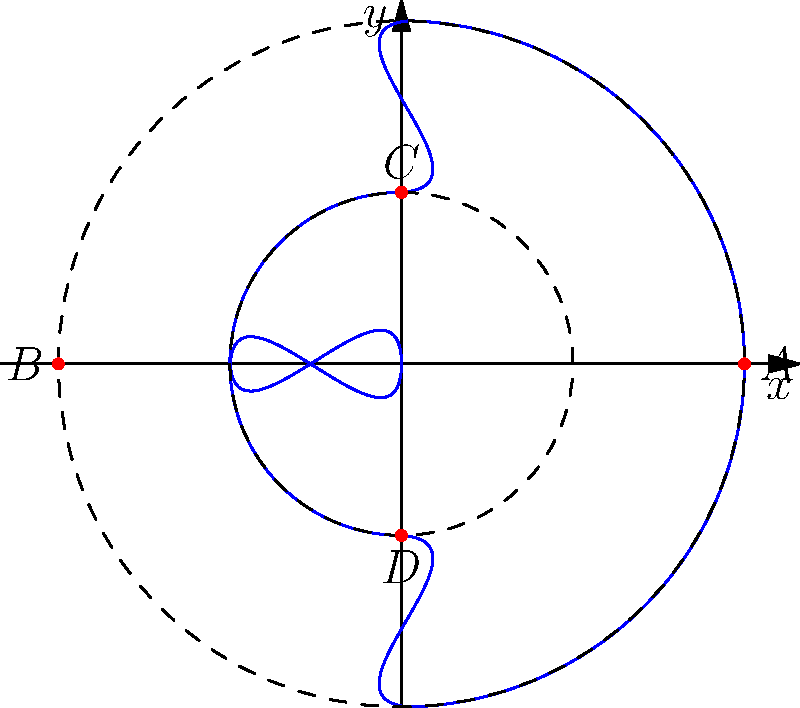As a junior engineer inspired by Craig Paylor's attention to detail, analyze the polar graph of the function $r(\theta)$ given by:

$$r(\theta) = \begin{cases}
2, & \text{if } 0 \leq \theta < \frac{\pi}{2} \text{ or } \frac{3\pi}{2} < \theta \leq 2\pi \\
1, & \text{if } \frac{\pi}{2} < \theta < \pi \text{ or } \pi < \theta < \frac{3\pi}{2} \\
0, & \text{if } \theta = \pi
\end{cases}$$

Identify the coordinates of points A, B, C, and D in rectangular form, and determine which point represents the function's discontinuity. Let's approach this step-by-step:

1) First, let's understand what the function represents:
   - For $0 \leq \theta < \frac{\pi}{2}$ and $\frac{3\pi}{2} < \theta \leq 2\pi$, $r = 2$ (outer circle)
   - For $\frac{\pi}{2} < \theta < \pi$ and $\pi < \theta < \frac{3\pi}{2}$, $r = 1$ (inner circle)
   - At $\theta = \pi$, $r = 0$ (origin)

2) Now, let's identify each point:

   Point A: At $\theta = 0$, $r = 2$
   - In polar form: $(2, 0)$
   - In rectangular form: $(2, 0)$

   Point B: At $\theta = \pi$, $r = 2$
   - In polar form: $(2, \pi)$
   - In rectangular form: $(-2, 0)$

   Point C: At $\theta = \frac{\pi}{2}$, $r = 1$
   - In polar form: $(1, \frac{\pi}{2})$
   - In rectangular form: $(0, 1)$

   Point D: At $\theta = \frac{3\pi}{2}$, $r = 1$
   - In polar form: $(1, \frac{3\pi}{2})$
   - In rectangular form: $(0, -1)$

3) The function's discontinuity occurs at $\theta = \pi$, where $r$ suddenly drops to 0.
   This corresponds to point $(0, 0)$ in rectangular coordinates, which is not labeled in the graph.

4) Among the labeled points, B is closest to this discontinuity, as it represents the limit of the function as $\theta$ approaches $\pi$ from both sides.
Answer: A(2,0), B(-2,0), C(0,1), D(0,-1); B is closest to the discontinuity. 